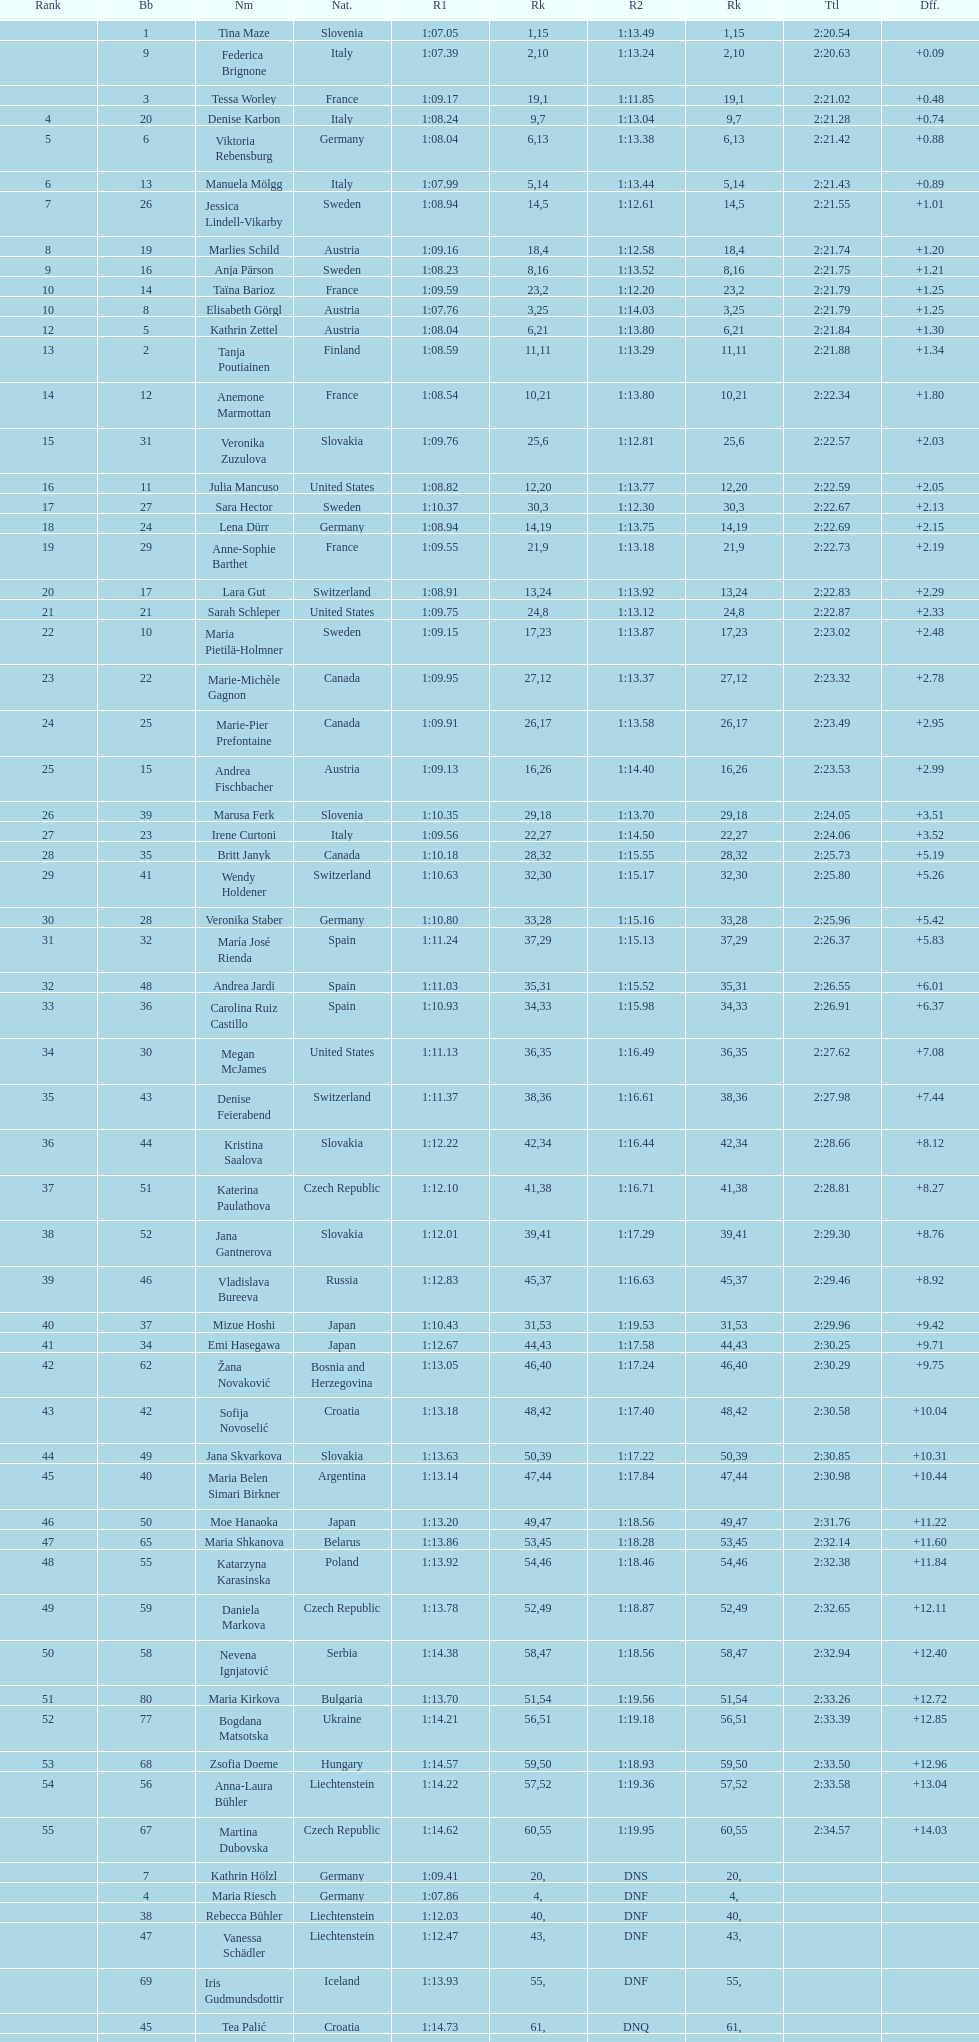How many italians ended up in the top ten positions? 3. 